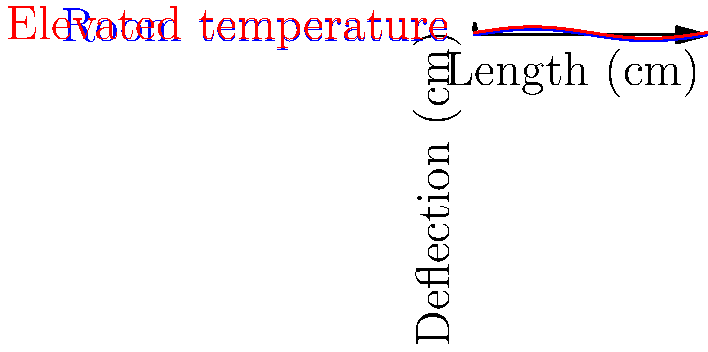A bimetallic strip is made of two metals with different coefficients of thermal expansion. The strip is 20 cm long and initially straight at room temperature (25°C). When heated to 100°C, it bends as shown in the diagram. If the maximum deflection at the center of the strip is 0.2 cm, calculate the difference in thermal expansion coefficients between the two metals. To solve this problem, we'll follow these steps:

1) The bending of a bimetallic strip can be approximated as an arc of a circle. The deflection (d) at the center is related to the radius of curvature (R) and the length of the strip (L) by the equation:

   $$d = \frac{L^2}{8R}$$

2) The radius of curvature is related to the difference in thermal expansion coefficients (Δα), the temperature change (ΔT), and the thickness of the strip (t) by:

   $$\frac{1}{R} = \frac{3(\Delta \alpha)(\Delta T)}{t}$$

3) We know:
   L = 20 cm
   d = 0.2 cm
   ΔT = 100°C - 25°C = 75°C

4) From the first equation:

   $$0.2 = \frac{20^2}{8R}$$
   $$R = \frac{400}{1.6} = 250 \text{ cm}$$

5) Substituting this into the second equation:

   $$\frac{1}{250} = \frac{3(\Delta \alpha)(75)}{t}$$

6) Solving for Δα:

   $$\Delta \alpha = \frac{t}{3 \cdot 250 \cdot 75} = \frac{t}{56250} \text{ °C}^{-1}$$

7) The thickness t is not given, but it's typically in the range of millimeters. Let's assume t = 1 mm = 0.1 cm.

8) Final calculation:

   $$\Delta \alpha = \frac{0.1}{56250} = 1.78 \times 10^{-6} \text{ °C}^{-1}$$
Answer: $1.78 \times 10^{-6} \text{ °C}^{-1}$ 